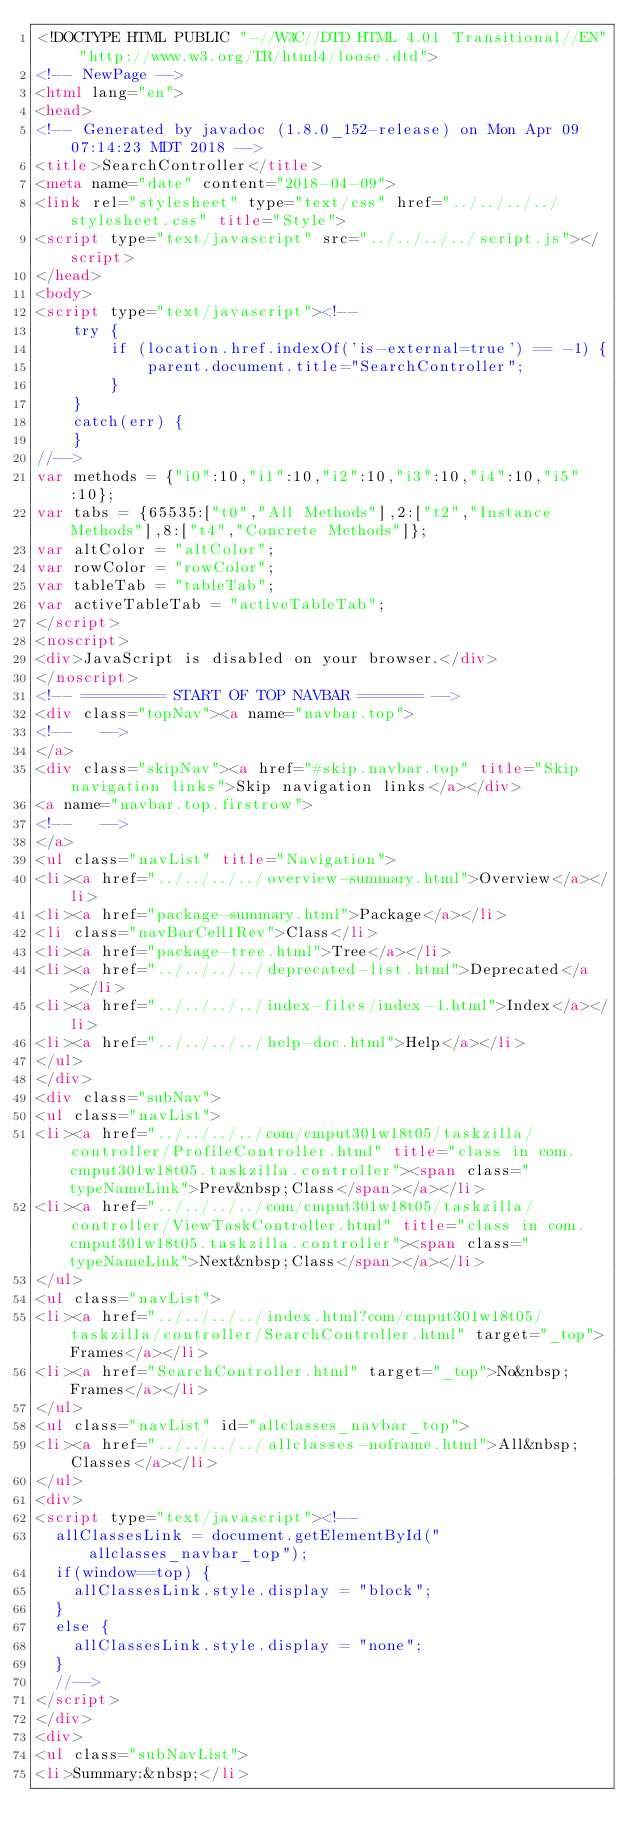Convert code to text. <code><loc_0><loc_0><loc_500><loc_500><_HTML_><!DOCTYPE HTML PUBLIC "-//W3C//DTD HTML 4.01 Transitional//EN" "http://www.w3.org/TR/html4/loose.dtd">
<!-- NewPage -->
<html lang="en">
<head>
<!-- Generated by javadoc (1.8.0_152-release) on Mon Apr 09 07:14:23 MDT 2018 -->
<title>SearchController</title>
<meta name="date" content="2018-04-09">
<link rel="stylesheet" type="text/css" href="../../../../stylesheet.css" title="Style">
<script type="text/javascript" src="../../../../script.js"></script>
</head>
<body>
<script type="text/javascript"><!--
    try {
        if (location.href.indexOf('is-external=true') == -1) {
            parent.document.title="SearchController";
        }
    }
    catch(err) {
    }
//-->
var methods = {"i0":10,"i1":10,"i2":10,"i3":10,"i4":10,"i5":10};
var tabs = {65535:["t0","All Methods"],2:["t2","Instance Methods"],8:["t4","Concrete Methods"]};
var altColor = "altColor";
var rowColor = "rowColor";
var tableTab = "tableTab";
var activeTableTab = "activeTableTab";
</script>
<noscript>
<div>JavaScript is disabled on your browser.</div>
</noscript>
<!-- ========= START OF TOP NAVBAR ======= -->
<div class="topNav"><a name="navbar.top">
<!--   -->
</a>
<div class="skipNav"><a href="#skip.navbar.top" title="Skip navigation links">Skip navigation links</a></div>
<a name="navbar.top.firstrow">
<!--   -->
</a>
<ul class="navList" title="Navigation">
<li><a href="../../../../overview-summary.html">Overview</a></li>
<li><a href="package-summary.html">Package</a></li>
<li class="navBarCell1Rev">Class</li>
<li><a href="package-tree.html">Tree</a></li>
<li><a href="../../../../deprecated-list.html">Deprecated</a></li>
<li><a href="../../../../index-files/index-1.html">Index</a></li>
<li><a href="../../../../help-doc.html">Help</a></li>
</ul>
</div>
<div class="subNav">
<ul class="navList">
<li><a href="../../../../com/cmput301w18t05/taskzilla/controller/ProfileController.html" title="class in com.cmput301w18t05.taskzilla.controller"><span class="typeNameLink">Prev&nbsp;Class</span></a></li>
<li><a href="../../../../com/cmput301w18t05/taskzilla/controller/ViewTaskController.html" title="class in com.cmput301w18t05.taskzilla.controller"><span class="typeNameLink">Next&nbsp;Class</span></a></li>
</ul>
<ul class="navList">
<li><a href="../../../../index.html?com/cmput301w18t05/taskzilla/controller/SearchController.html" target="_top">Frames</a></li>
<li><a href="SearchController.html" target="_top">No&nbsp;Frames</a></li>
</ul>
<ul class="navList" id="allclasses_navbar_top">
<li><a href="../../../../allclasses-noframe.html">All&nbsp;Classes</a></li>
</ul>
<div>
<script type="text/javascript"><!--
  allClassesLink = document.getElementById("allclasses_navbar_top");
  if(window==top) {
    allClassesLink.style.display = "block";
  }
  else {
    allClassesLink.style.display = "none";
  }
  //-->
</script>
</div>
<div>
<ul class="subNavList">
<li>Summary:&nbsp;</li></code> 